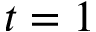Convert formula to latex. <formula><loc_0><loc_0><loc_500><loc_500>t = 1</formula> 